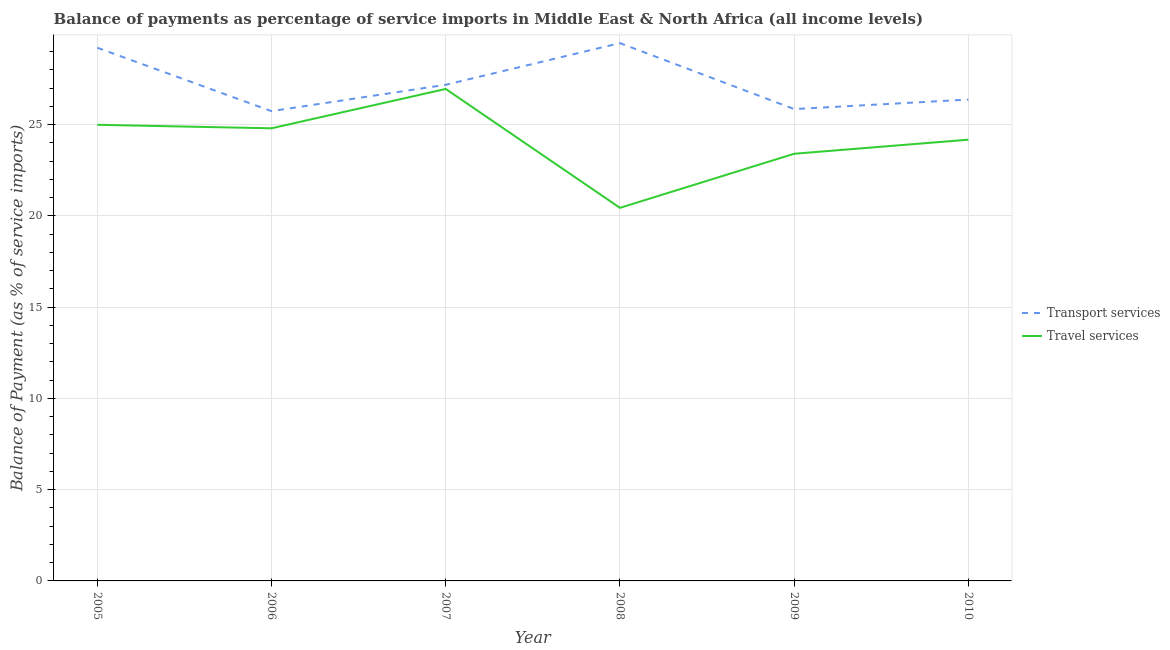What is the balance of payments of travel services in 2007?
Provide a succinct answer. 26.95. Across all years, what is the maximum balance of payments of travel services?
Offer a very short reply. 26.95. Across all years, what is the minimum balance of payments of travel services?
Provide a short and direct response. 20.44. In which year was the balance of payments of transport services minimum?
Your answer should be very brief. 2006. What is the total balance of payments of travel services in the graph?
Make the answer very short. 144.75. What is the difference between the balance of payments of travel services in 2007 and that in 2010?
Give a very brief answer. 2.78. What is the difference between the balance of payments of transport services in 2010 and the balance of payments of travel services in 2008?
Your answer should be very brief. 5.93. What is the average balance of payments of transport services per year?
Provide a succinct answer. 27.3. In the year 2009, what is the difference between the balance of payments of transport services and balance of payments of travel services?
Your response must be concise. 2.45. What is the ratio of the balance of payments of travel services in 2008 to that in 2010?
Provide a succinct answer. 0.85. Is the balance of payments of travel services in 2008 less than that in 2009?
Your answer should be very brief. Yes. Is the difference between the balance of payments of travel services in 2006 and 2009 greater than the difference between the balance of payments of transport services in 2006 and 2009?
Keep it short and to the point. Yes. What is the difference between the highest and the second highest balance of payments of travel services?
Provide a succinct answer. 1.96. What is the difference between the highest and the lowest balance of payments of transport services?
Keep it short and to the point. 3.73. Is the sum of the balance of payments of travel services in 2007 and 2008 greater than the maximum balance of payments of transport services across all years?
Keep it short and to the point. Yes. Is the balance of payments of travel services strictly less than the balance of payments of transport services over the years?
Your response must be concise. Yes. How many years are there in the graph?
Give a very brief answer. 6. What is the difference between two consecutive major ticks on the Y-axis?
Provide a short and direct response. 5. What is the title of the graph?
Ensure brevity in your answer.  Balance of payments as percentage of service imports in Middle East & North Africa (all income levels). Does "Female labor force" appear as one of the legend labels in the graph?
Provide a succinct answer. No. What is the label or title of the Y-axis?
Make the answer very short. Balance of Payment (as % of service imports). What is the Balance of Payment (as % of service imports) of Transport services in 2005?
Keep it short and to the point. 29.21. What is the Balance of Payment (as % of service imports) of Travel services in 2005?
Your response must be concise. 24.99. What is the Balance of Payment (as % of service imports) in Transport services in 2006?
Keep it short and to the point. 25.74. What is the Balance of Payment (as % of service imports) of Travel services in 2006?
Provide a succinct answer. 24.8. What is the Balance of Payment (as % of service imports) of Transport services in 2007?
Your response must be concise. 27.18. What is the Balance of Payment (as % of service imports) in Travel services in 2007?
Make the answer very short. 26.95. What is the Balance of Payment (as % of service imports) in Transport services in 2008?
Offer a very short reply. 29.46. What is the Balance of Payment (as % of service imports) in Travel services in 2008?
Your response must be concise. 20.44. What is the Balance of Payment (as % of service imports) in Transport services in 2009?
Ensure brevity in your answer.  25.85. What is the Balance of Payment (as % of service imports) in Travel services in 2009?
Keep it short and to the point. 23.4. What is the Balance of Payment (as % of service imports) in Transport services in 2010?
Your answer should be compact. 26.37. What is the Balance of Payment (as % of service imports) in Travel services in 2010?
Provide a succinct answer. 24.17. Across all years, what is the maximum Balance of Payment (as % of service imports) of Transport services?
Provide a succinct answer. 29.46. Across all years, what is the maximum Balance of Payment (as % of service imports) of Travel services?
Offer a very short reply. 26.95. Across all years, what is the minimum Balance of Payment (as % of service imports) of Transport services?
Provide a short and direct response. 25.74. Across all years, what is the minimum Balance of Payment (as % of service imports) in Travel services?
Keep it short and to the point. 20.44. What is the total Balance of Payment (as % of service imports) of Transport services in the graph?
Provide a short and direct response. 163.81. What is the total Balance of Payment (as % of service imports) in Travel services in the graph?
Provide a succinct answer. 144.75. What is the difference between the Balance of Payment (as % of service imports) in Transport services in 2005 and that in 2006?
Your answer should be very brief. 3.47. What is the difference between the Balance of Payment (as % of service imports) of Travel services in 2005 and that in 2006?
Your answer should be very brief. 0.19. What is the difference between the Balance of Payment (as % of service imports) of Transport services in 2005 and that in 2007?
Your response must be concise. 2.03. What is the difference between the Balance of Payment (as % of service imports) in Travel services in 2005 and that in 2007?
Provide a short and direct response. -1.96. What is the difference between the Balance of Payment (as % of service imports) of Transport services in 2005 and that in 2008?
Ensure brevity in your answer.  -0.25. What is the difference between the Balance of Payment (as % of service imports) in Travel services in 2005 and that in 2008?
Your answer should be very brief. 4.55. What is the difference between the Balance of Payment (as % of service imports) of Transport services in 2005 and that in 2009?
Ensure brevity in your answer.  3.36. What is the difference between the Balance of Payment (as % of service imports) in Travel services in 2005 and that in 2009?
Ensure brevity in your answer.  1.59. What is the difference between the Balance of Payment (as % of service imports) of Transport services in 2005 and that in 2010?
Provide a short and direct response. 2.84. What is the difference between the Balance of Payment (as % of service imports) in Travel services in 2005 and that in 2010?
Offer a terse response. 0.82. What is the difference between the Balance of Payment (as % of service imports) of Transport services in 2006 and that in 2007?
Provide a short and direct response. -1.44. What is the difference between the Balance of Payment (as % of service imports) of Travel services in 2006 and that in 2007?
Provide a succinct answer. -2.16. What is the difference between the Balance of Payment (as % of service imports) of Transport services in 2006 and that in 2008?
Offer a very short reply. -3.73. What is the difference between the Balance of Payment (as % of service imports) of Travel services in 2006 and that in 2008?
Offer a terse response. 4.36. What is the difference between the Balance of Payment (as % of service imports) in Transport services in 2006 and that in 2009?
Provide a succinct answer. -0.11. What is the difference between the Balance of Payment (as % of service imports) of Travel services in 2006 and that in 2009?
Ensure brevity in your answer.  1.39. What is the difference between the Balance of Payment (as % of service imports) of Transport services in 2006 and that in 2010?
Keep it short and to the point. -0.63. What is the difference between the Balance of Payment (as % of service imports) of Travel services in 2006 and that in 2010?
Provide a succinct answer. 0.62. What is the difference between the Balance of Payment (as % of service imports) of Transport services in 2007 and that in 2008?
Provide a short and direct response. -2.28. What is the difference between the Balance of Payment (as % of service imports) of Travel services in 2007 and that in 2008?
Make the answer very short. 6.51. What is the difference between the Balance of Payment (as % of service imports) of Transport services in 2007 and that in 2009?
Make the answer very short. 1.33. What is the difference between the Balance of Payment (as % of service imports) of Travel services in 2007 and that in 2009?
Offer a terse response. 3.55. What is the difference between the Balance of Payment (as % of service imports) of Transport services in 2007 and that in 2010?
Keep it short and to the point. 0.81. What is the difference between the Balance of Payment (as % of service imports) of Travel services in 2007 and that in 2010?
Your answer should be very brief. 2.78. What is the difference between the Balance of Payment (as % of service imports) of Transport services in 2008 and that in 2009?
Your answer should be very brief. 3.61. What is the difference between the Balance of Payment (as % of service imports) in Travel services in 2008 and that in 2009?
Keep it short and to the point. -2.96. What is the difference between the Balance of Payment (as % of service imports) in Transport services in 2008 and that in 2010?
Make the answer very short. 3.09. What is the difference between the Balance of Payment (as % of service imports) of Travel services in 2008 and that in 2010?
Provide a succinct answer. -3.73. What is the difference between the Balance of Payment (as % of service imports) of Transport services in 2009 and that in 2010?
Your response must be concise. -0.52. What is the difference between the Balance of Payment (as % of service imports) in Travel services in 2009 and that in 2010?
Ensure brevity in your answer.  -0.77. What is the difference between the Balance of Payment (as % of service imports) of Transport services in 2005 and the Balance of Payment (as % of service imports) of Travel services in 2006?
Provide a succinct answer. 4.41. What is the difference between the Balance of Payment (as % of service imports) of Transport services in 2005 and the Balance of Payment (as % of service imports) of Travel services in 2007?
Offer a very short reply. 2.26. What is the difference between the Balance of Payment (as % of service imports) of Transport services in 2005 and the Balance of Payment (as % of service imports) of Travel services in 2008?
Give a very brief answer. 8.77. What is the difference between the Balance of Payment (as % of service imports) of Transport services in 2005 and the Balance of Payment (as % of service imports) of Travel services in 2009?
Offer a very short reply. 5.81. What is the difference between the Balance of Payment (as % of service imports) of Transport services in 2005 and the Balance of Payment (as % of service imports) of Travel services in 2010?
Provide a succinct answer. 5.04. What is the difference between the Balance of Payment (as % of service imports) in Transport services in 2006 and the Balance of Payment (as % of service imports) in Travel services in 2007?
Ensure brevity in your answer.  -1.22. What is the difference between the Balance of Payment (as % of service imports) in Transport services in 2006 and the Balance of Payment (as % of service imports) in Travel services in 2008?
Your response must be concise. 5.3. What is the difference between the Balance of Payment (as % of service imports) of Transport services in 2006 and the Balance of Payment (as % of service imports) of Travel services in 2009?
Ensure brevity in your answer.  2.33. What is the difference between the Balance of Payment (as % of service imports) of Transport services in 2006 and the Balance of Payment (as % of service imports) of Travel services in 2010?
Provide a short and direct response. 1.56. What is the difference between the Balance of Payment (as % of service imports) of Transport services in 2007 and the Balance of Payment (as % of service imports) of Travel services in 2008?
Your response must be concise. 6.74. What is the difference between the Balance of Payment (as % of service imports) in Transport services in 2007 and the Balance of Payment (as % of service imports) in Travel services in 2009?
Your answer should be very brief. 3.78. What is the difference between the Balance of Payment (as % of service imports) in Transport services in 2007 and the Balance of Payment (as % of service imports) in Travel services in 2010?
Your answer should be very brief. 3.01. What is the difference between the Balance of Payment (as % of service imports) in Transport services in 2008 and the Balance of Payment (as % of service imports) in Travel services in 2009?
Your response must be concise. 6.06. What is the difference between the Balance of Payment (as % of service imports) in Transport services in 2008 and the Balance of Payment (as % of service imports) in Travel services in 2010?
Your answer should be very brief. 5.29. What is the difference between the Balance of Payment (as % of service imports) of Transport services in 2009 and the Balance of Payment (as % of service imports) of Travel services in 2010?
Ensure brevity in your answer.  1.68. What is the average Balance of Payment (as % of service imports) of Transport services per year?
Provide a succinct answer. 27.3. What is the average Balance of Payment (as % of service imports) of Travel services per year?
Your answer should be very brief. 24.13. In the year 2005, what is the difference between the Balance of Payment (as % of service imports) in Transport services and Balance of Payment (as % of service imports) in Travel services?
Ensure brevity in your answer.  4.22. In the year 2006, what is the difference between the Balance of Payment (as % of service imports) of Transport services and Balance of Payment (as % of service imports) of Travel services?
Keep it short and to the point. 0.94. In the year 2007, what is the difference between the Balance of Payment (as % of service imports) in Transport services and Balance of Payment (as % of service imports) in Travel services?
Give a very brief answer. 0.23. In the year 2008, what is the difference between the Balance of Payment (as % of service imports) of Transport services and Balance of Payment (as % of service imports) of Travel services?
Keep it short and to the point. 9.02. In the year 2009, what is the difference between the Balance of Payment (as % of service imports) in Transport services and Balance of Payment (as % of service imports) in Travel services?
Provide a succinct answer. 2.45. In the year 2010, what is the difference between the Balance of Payment (as % of service imports) of Transport services and Balance of Payment (as % of service imports) of Travel services?
Provide a succinct answer. 2.2. What is the ratio of the Balance of Payment (as % of service imports) in Transport services in 2005 to that in 2006?
Give a very brief answer. 1.14. What is the ratio of the Balance of Payment (as % of service imports) of Travel services in 2005 to that in 2006?
Your answer should be compact. 1.01. What is the ratio of the Balance of Payment (as % of service imports) in Transport services in 2005 to that in 2007?
Provide a succinct answer. 1.07. What is the ratio of the Balance of Payment (as % of service imports) of Travel services in 2005 to that in 2007?
Provide a short and direct response. 0.93. What is the ratio of the Balance of Payment (as % of service imports) of Travel services in 2005 to that in 2008?
Give a very brief answer. 1.22. What is the ratio of the Balance of Payment (as % of service imports) in Transport services in 2005 to that in 2009?
Give a very brief answer. 1.13. What is the ratio of the Balance of Payment (as % of service imports) in Travel services in 2005 to that in 2009?
Ensure brevity in your answer.  1.07. What is the ratio of the Balance of Payment (as % of service imports) of Transport services in 2005 to that in 2010?
Offer a very short reply. 1.11. What is the ratio of the Balance of Payment (as % of service imports) in Travel services in 2005 to that in 2010?
Offer a very short reply. 1.03. What is the ratio of the Balance of Payment (as % of service imports) in Transport services in 2006 to that in 2007?
Give a very brief answer. 0.95. What is the ratio of the Balance of Payment (as % of service imports) in Travel services in 2006 to that in 2007?
Offer a terse response. 0.92. What is the ratio of the Balance of Payment (as % of service imports) of Transport services in 2006 to that in 2008?
Ensure brevity in your answer.  0.87. What is the ratio of the Balance of Payment (as % of service imports) of Travel services in 2006 to that in 2008?
Your answer should be very brief. 1.21. What is the ratio of the Balance of Payment (as % of service imports) in Transport services in 2006 to that in 2009?
Ensure brevity in your answer.  1. What is the ratio of the Balance of Payment (as % of service imports) in Travel services in 2006 to that in 2009?
Ensure brevity in your answer.  1.06. What is the ratio of the Balance of Payment (as % of service imports) in Transport services in 2006 to that in 2010?
Your answer should be very brief. 0.98. What is the ratio of the Balance of Payment (as % of service imports) of Travel services in 2006 to that in 2010?
Your answer should be very brief. 1.03. What is the ratio of the Balance of Payment (as % of service imports) in Transport services in 2007 to that in 2008?
Ensure brevity in your answer.  0.92. What is the ratio of the Balance of Payment (as % of service imports) of Travel services in 2007 to that in 2008?
Your answer should be compact. 1.32. What is the ratio of the Balance of Payment (as % of service imports) of Transport services in 2007 to that in 2009?
Provide a succinct answer. 1.05. What is the ratio of the Balance of Payment (as % of service imports) of Travel services in 2007 to that in 2009?
Give a very brief answer. 1.15. What is the ratio of the Balance of Payment (as % of service imports) of Transport services in 2007 to that in 2010?
Offer a very short reply. 1.03. What is the ratio of the Balance of Payment (as % of service imports) in Travel services in 2007 to that in 2010?
Give a very brief answer. 1.11. What is the ratio of the Balance of Payment (as % of service imports) in Transport services in 2008 to that in 2009?
Your answer should be very brief. 1.14. What is the ratio of the Balance of Payment (as % of service imports) in Travel services in 2008 to that in 2009?
Offer a terse response. 0.87. What is the ratio of the Balance of Payment (as % of service imports) of Transport services in 2008 to that in 2010?
Ensure brevity in your answer.  1.12. What is the ratio of the Balance of Payment (as % of service imports) in Travel services in 2008 to that in 2010?
Offer a terse response. 0.85. What is the ratio of the Balance of Payment (as % of service imports) in Transport services in 2009 to that in 2010?
Your response must be concise. 0.98. What is the ratio of the Balance of Payment (as % of service imports) in Travel services in 2009 to that in 2010?
Keep it short and to the point. 0.97. What is the difference between the highest and the second highest Balance of Payment (as % of service imports) of Transport services?
Provide a succinct answer. 0.25. What is the difference between the highest and the second highest Balance of Payment (as % of service imports) in Travel services?
Your response must be concise. 1.96. What is the difference between the highest and the lowest Balance of Payment (as % of service imports) of Transport services?
Give a very brief answer. 3.73. What is the difference between the highest and the lowest Balance of Payment (as % of service imports) of Travel services?
Offer a very short reply. 6.51. 